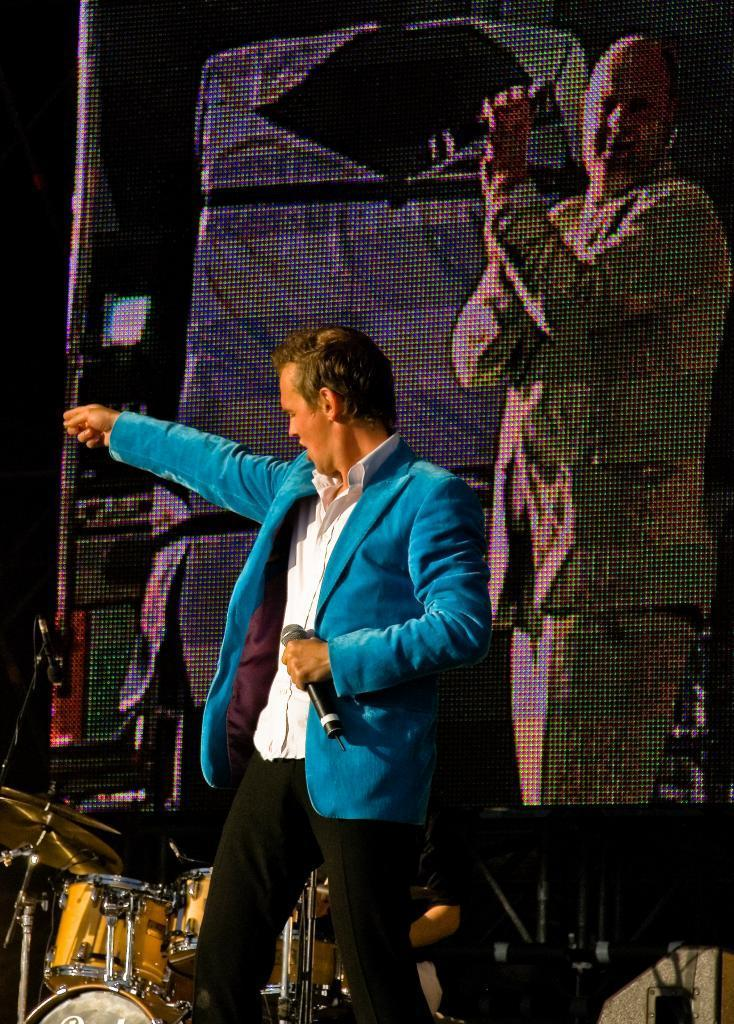What is the person in the image doing? The person in the image is holding a microphone. What is the person wearing in the image? The person is wearing a blue jacket. What objects are in front of the person in the image? There are musical instruments in front of the person. What can be seen at the top of the image? There is an image of a person at the top of the image. How many ducks are visible in the image? There are no ducks present in the image. What type of beggar can be seen in the image? There is no beggar present in the image. 